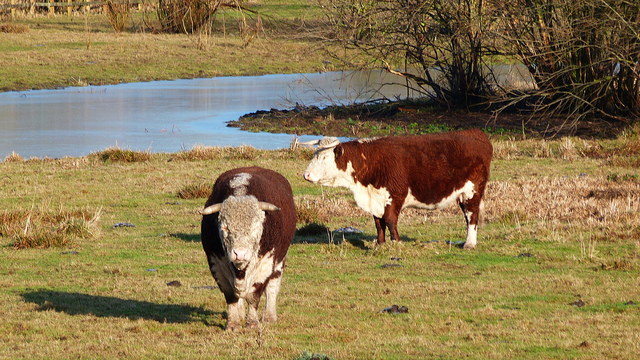How many cows can be seen? In the image, there are two cows peacefully grazing in what appears to be a pasture. One cow has a predominantly white body with dark patches, while the other is mostly reddish-brown with a white face and belly. 